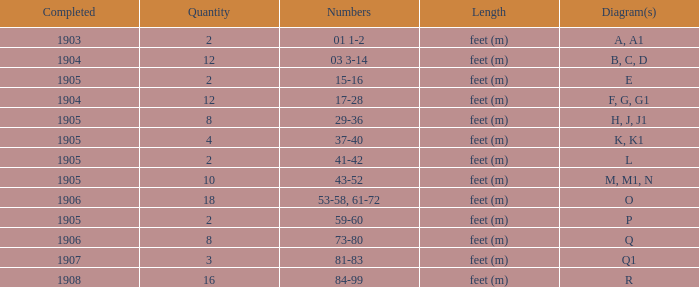For the item with more than 10, and numbers of 53-58, 61-72, what is the lowest completed? 1906.0. Would you mind parsing the complete table? {'header': ['Completed', 'Quantity', 'Numbers', 'Length', 'Diagram(s)'], 'rows': [['1903', '2', '01 1-2', 'feet (m)', 'A, A1'], ['1904', '12', '03 3-14', 'feet (m)', 'B, C, D'], ['1905', '2', '15-16', 'feet (m)', 'E'], ['1904', '12', '17-28', 'feet (m)', 'F, G, G1'], ['1905', '8', '29-36', 'feet (m)', 'H, J, J1'], ['1905', '4', '37-40', 'feet (m)', 'K, K1'], ['1905', '2', '41-42', 'feet (m)', 'L'], ['1905', '10', '43-52', 'feet (m)', 'M, M1, N'], ['1906', '18', '53-58, 61-72', 'feet (m)', 'O'], ['1905', '2', '59-60', 'feet (m)', 'P'], ['1906', '8', '73-80', 'feet (m)', 'Q'], ['1907', '3', '81-83', 'feet (m)', 'Q1'], ['1908', '16', '84-99', 'feet (m)', 'R']]} 